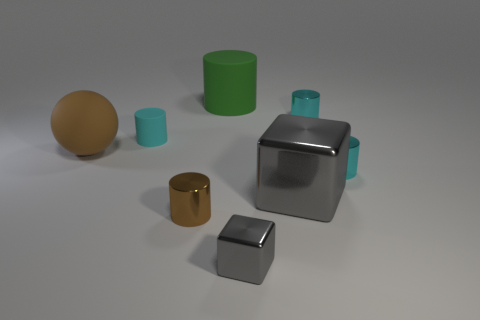Is the color of the large block the same as the small block?
Your answer should be very brief. Yes. There is a object that is in front of the tiny brown cylinder; is it the same shape as the large metal thing?
Your answer should be very brief. Yes. What is the color of the shiny thing behind the brown rubber sphere?
Your answer should be compact. Cyan. There is a large brown thing that is the same material as the green thing; what is its shape?
Provide a short and direct response. Sphere. Is there any other thing of the same color as the small cube?
Offer a terse response. Yes. Are there more small objects that are in front of the large cylinder than small cyan things that are to the right of the big metallic cube?
Ensure brevity in your answer.  Yes. How many red metallic cylinders have the same size as the cyan rubber cylinder?
Give a very brief answer. 0. Is the number of brown metallic things that are to the right of the brown rubber sphere less than the number of things that are to the right of the tiny brown thing?
Keep it short and to the point. Yes. Is there a small brown object of the same shape as the cyan matte thing?
Make the answer very short. Yes. Does the small gray object have the same shape as the cyan matte thing?
Ensure brevity in your answer.  No. 